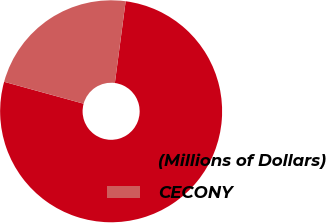Convert chart to OTSL. <chart><loc_0><loc_0><loc_500><loc_500><pie_chart><fcel>(Millions of Dollars)<fcel>CECONY<nl><fcel>77.19%<fcel>22.81%<nl></chart> 